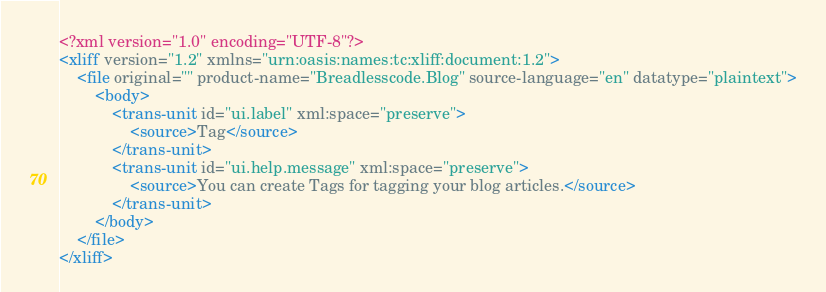<code> <loc_0><loc_0><loc_500><loc_500><_XML_><?xml version="1.0" encoding="UTF-8"?>
<xliff version="1.2" xmlns="urn:oasis:names:tc:xliff:document:1.2">
    <file original="" product-name="Breadlesscode.Blog" source-language="en" datatype="plaintext">
        <body>
            <trans-unit id="ui.label" xml:space="preserve">
                <source>Tag</source>
            </trans-unit>
            <trans-unit id="ui.help.message" xml:space="preserve">
                <source>You can create Tags for tagging your blog articles.</source>
            </trans-unit>
        </body>
    </file>
</xliff></code> 